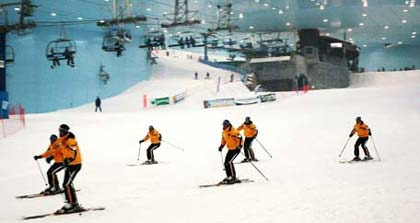How many skiers are present in the image? There are five skiers noticeably visible in the image. 